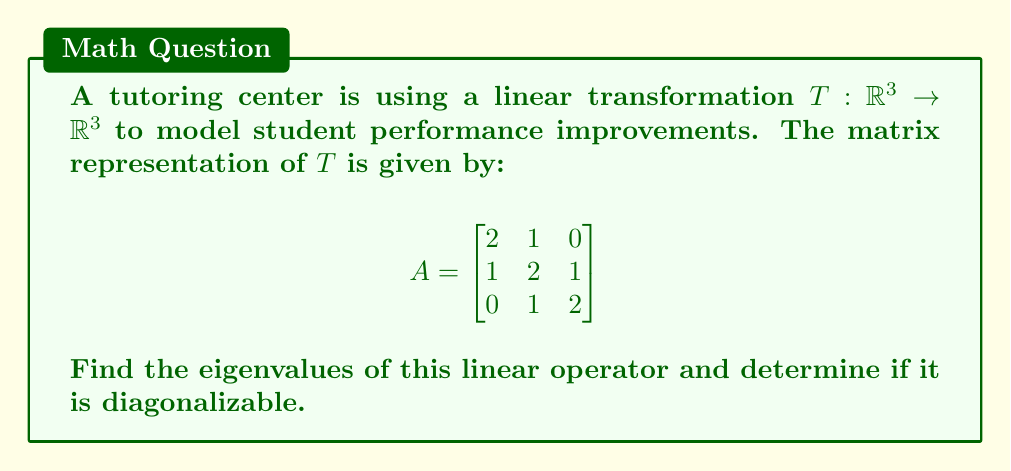Solve this math problem. 1) To find the eigenvalues, we need to solve the characteristic equation:
   $$det(A - \lambda I) = 0$$

2) Expanding the determinant:
   $$\begin{vmatrix}
   2-\lambda & 1 & 0 \\
   1 & 2-\lambda & 1 \\
   0 & 1 & 2-\lambda
   \end{vmatrix} = 0$$

3) Calculating the determinant:
   $$(2-\lambda)[(2-\lambda)(2-\lambda) - 1] - 1(1(2-\lambda) - 0) = 0$$
   $$(2-\lambda)[(4-4\lambda+\lambda^2) - 1] - (2-\lambda) = 0$$
   $$(2-\lambda)(\lambda^2-4\lambda+3) - (2-\lambda) = 0$$
   $$2\lambda^2-8\lambda+6-\lambda^3+4\lambda^2-3\lambda-2+\lambda = 0$$
   $$-\lambda^3+6\lambda^2-10\lambda+4 = 0$$
   $$-(\lambda-1)(\lambda-2)(\lambda-3) = 0$$

4) Solving this equation, we get the eigenvalues:
   $$\lambda_1 = 1, \lambda_2 = 2, \lambda_3 = 3$$

5) To determine if $A$ is diagonalizable, we need to check if there are 3 linearly independent eigenvectors (since the dimension of the space is 3).

6) For $\lambda_1 = 1$:
   $$(A - I)v = 0$$
   $$\begin{bmatrix}
   1 & 1 & 0 \\
   1 & 1 & 1 \\
   0 & 1 & 1
   \end{bmatrix}v = 0$$
   This gives us the eigenvector $v_1 = (1, -1, 1)^T$

7) For $\lambda_2 = 2$:
   $$(A - 2I)v = 0$$
   $$\begin{bmatrix}
   0 & 1 & 0 \\
   1 & 0 & 1 \\
   0 & 1 & 0
   \end{bmatrix}v = 0$$
   This gives us the eigenvector $v_2 = (1, 0, -1)^T$

8) For $\lambda_3 = 3$:
   $$(A - 3I)v = 0$$
   $$\begin{bmatrix}
   -1 & 1 & 0 \\
   1 & -1 & 1 \\
   0 & 1 & -1
   \end{bmatrix}v = 0$$
   This gives us the eigenvector $v_3 = (1, 1, 1)^T$

9) These three eigenvectors are linearly independent, so $A$ is diagonalizable.
Answer: Eigenvalues: 1, 2, 3; Diagonalizable: Yes 